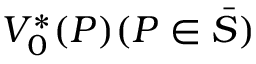<formula> <loc_0><loc_0><loc_500><loc_500>V _ { 0 } ^ { * } ( P ) ( P \in \bar { S } )</formula> 